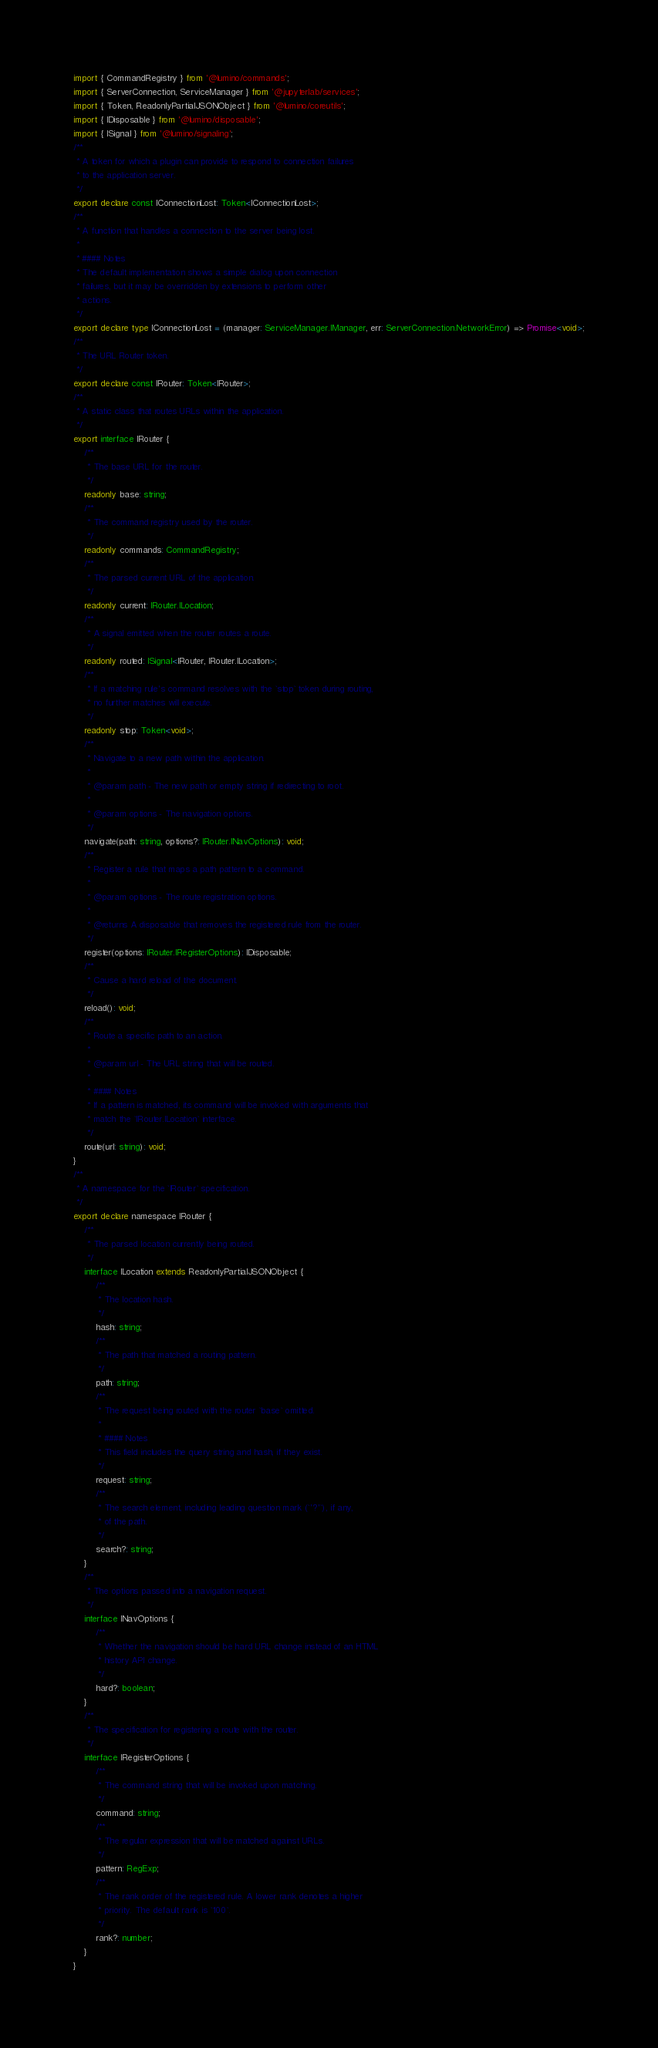<code> <loc_0><loc_0><loc_500><loc_500><_TypeScript_>import { CommandRegistry } from '@lumino/commands';
import { ServerConnection, ServiceManager } from '@jupyterlab/services';
import { Token, ReadonlyPartialJSONObject } from '@lumino/coreutils';
import { IDisposable } from '@lumino/disposable';
import { ISignal } from '@lumino/signaling';
/**
 * A token for which a plugin can provide to respond to connection failures
 * to the application server.
 */
export declare const IConnectionLost: Token<IConnectionLost>;
/**
 * A function that handles a connection to the server being lost.
 *
 * #### Notes
 * The default implementation shows a simple dialog upon connection
 * failures, but it may be overridden by extensions to perform other
 * actions.
 */
export declare type IConnectionLost = (manager: ServiceManager.IManager, err: ServerConnection.NetworkError) => Promise<void>;
/**
 * The URL Router token.
 */
export declare const IRouter: Token<IRouter>;
/**
 * A static class that routes URLs within the application.
 */
export interface IRouter {
    /**
     * The base URL for the router.
     */
    readonly base: string;
    /**
     * The command registry used by the router.
     */
    readonly commands: CommandRegistry;
    /**
     * The parsed current URL of the application.
     */
    readonly current: IRouter.ILocation;
    /**
     * A signal emitted when the router routes a route.
     */
    readonly routed: ISignal<IRouter, IRouter.ILocation>;
    /**
     * If a matching rule's command resolves with the `stop` token during routing,
     * no further matches will execute.
     */
    readonly stop: Token<void>;
    /**
     * Navigate to a new path within the application.
     *
     * @param path - The new path or empty string if redirecting to root.
     *
     * @param options - The navigation options.
     */
    navigate(path: string, options?: IRouter.INavOptions): void;
    /**
     * Register a rule that maps a path pattern to a command.
     *
     * @param options - The route registration options.
     *
     * @returns A disposable that removes the registered rule from the router.
     */
    register(options: IRouter.IRegisterOptions): IDisposable;
    /**
     * Cause a hard reload of the document.
     */
    reload(): void;
    /**
     * Route a specific path to an action.
     *
     * @param url - The URL string that will be routed.
     *
     * #### Notes
     * If a pattern is matched, its command will be invoked with arguments that
     * match the `IRouter.ILocation` interface.
     */
    route(url: string): void;
}
/**
 * A namespace for the `IRouter` specification.
 */
export declare namespace IRouter {
    /**
     * The parsed location currently being routed.
     */
    interface ILocation extends ReadonlyPartialJSONObject {
        /**
         * The location hash.
         */
        hash: string;
        /**
         * The path that matched a routing pattern.
         */
        path: string;
        /**
         * The request being routed with the router `base` omitted.
         *
         * #### Notes
         * This field includes the query string and hash, if they exist.
         */
        request: string;
        /**
         * The search element, including leading question mark (`'?'`), if any,
         * of the path.
         */
        search?: string;
    }
    /**
     * The options passed into a navigation request.
     */
    interface INavOptions {
        /**
         * Whether the navigation should be hard URL change instead of an HTML
         * history API change.
         */
        hard?: boolean;
    }
    /**
     * The specification for registering a route with the router.
     */
    interface IRegisterOptions {
        /**
         * The command string that will be invoked upon matching.
         */
        command: string;
        /**
         * The regular expression that will be matched against URLs.
         */
        pattern: RegExp;
        /**
         * The rank order of the registered rule. A lower rank denotes a higher
         * priority. The default rank is `100`.
         */
        rank?: number;
    }
}
</code> 